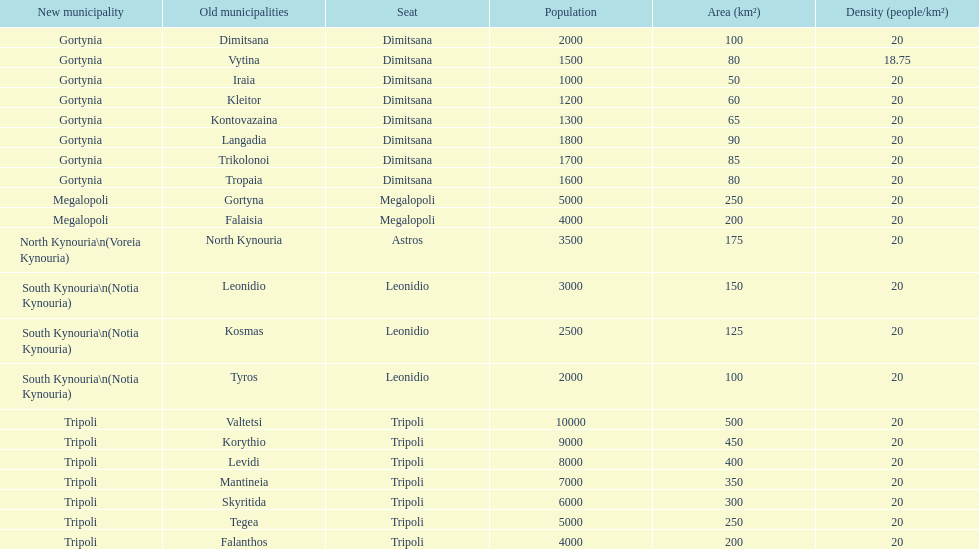What is the novel municipality of tyros? South Kynouria. 